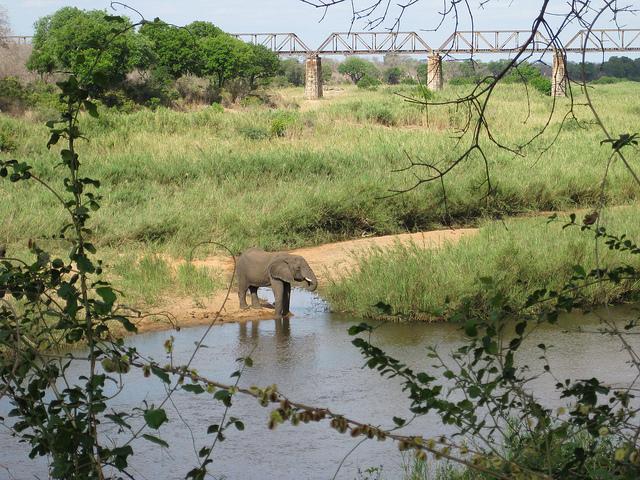How many elephants are viewed here?
Keep it brief. 1. What animals are these?
Answer briefly. Elephant. Is there water in the picture?
Give a very brief answer. Yes. What structure is in the background?
Write a very short answer. Bridge. Is that a baby elephant?
Answer briefly. Yes. 